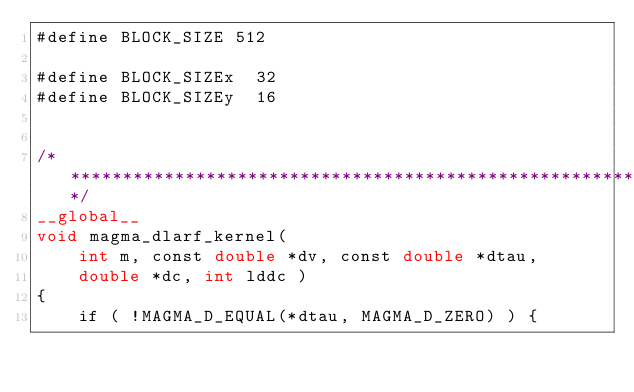Convert code to text. <code><loc_0><loc_0><loc_500><loc_500><_Cuda_>#define BLOCK_SIZE 512

#define BLOCK_SIZEx  32
#define BLOCK_SIZEy  16


/******************************************************************************/
__global__
void magma_dlarf_kernel(
    int m, const double *dv, const double *dtau,
    double *dc, int lddc )
{
    if ( !MAGMA_D_EQUAL(*dtau, MAGMA_D_ZERO) ) {</code> 